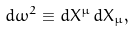Convert formula to latex. <formula><loc_0><loc_0><loc_500><loc_500>d \omega ^ { 2 } \equiv d X ^ { \mu } \, d X _ { \mu } ,</formula> 